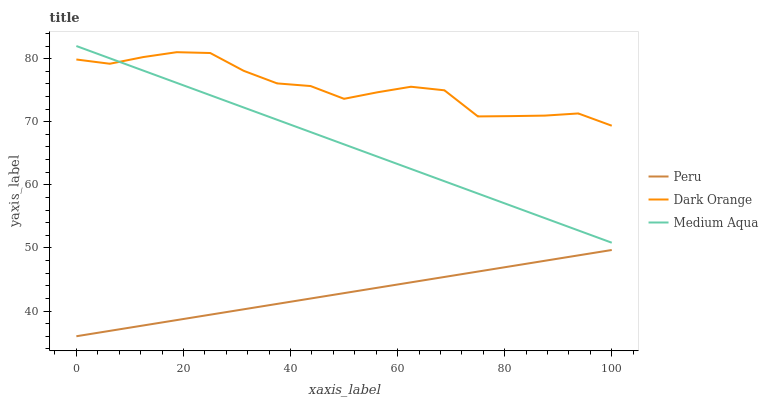Does Peru have the minimum area under the curve?
Answer yes or no. Yes. Does Dark Orange have the maximum area under the curve?
Answer yes or no. Yes. Does Medium Aqua have the minimum area under the curve?
Answer yes or no. No. Does Medium Aqua have the maximum area under the curve?
Answer yes or no. No. Is Peru the smoothest?
Answer yes or no. Yes. Is Dark Orange the roughest?
Answer yes or no. Yes. Is Medium Aqua the smoothest?
Answer yes or no. No. Is Medium Aqua the roughest?
Answer yes or no. No. Does Peru have the lowest value?
Answer yes or no. Yes. Does Medium Aqua have the lowest value?
Answer yes or no. No. Does Medium Aqua have the highest value?
Answer yes or no. Yes. Does Peru have the highest value?
Answer yes or no. No. Is Peru less than Medium Aqua?
Answer yes or no. Yes. Is Dark Orange greater than Peru?
Answer yes or no. Yes. Does Medium Aqua intersect Dark Orange?
Answer yes or no. Yes. Is Medium Aqua less than Dark Orange?
Answer yes or no. No. Is Medium Aqua greater than Dark Orange?
Answer yes or no. No. Does Peru intersect Medium Aqua?
Answer yes or no. No. 